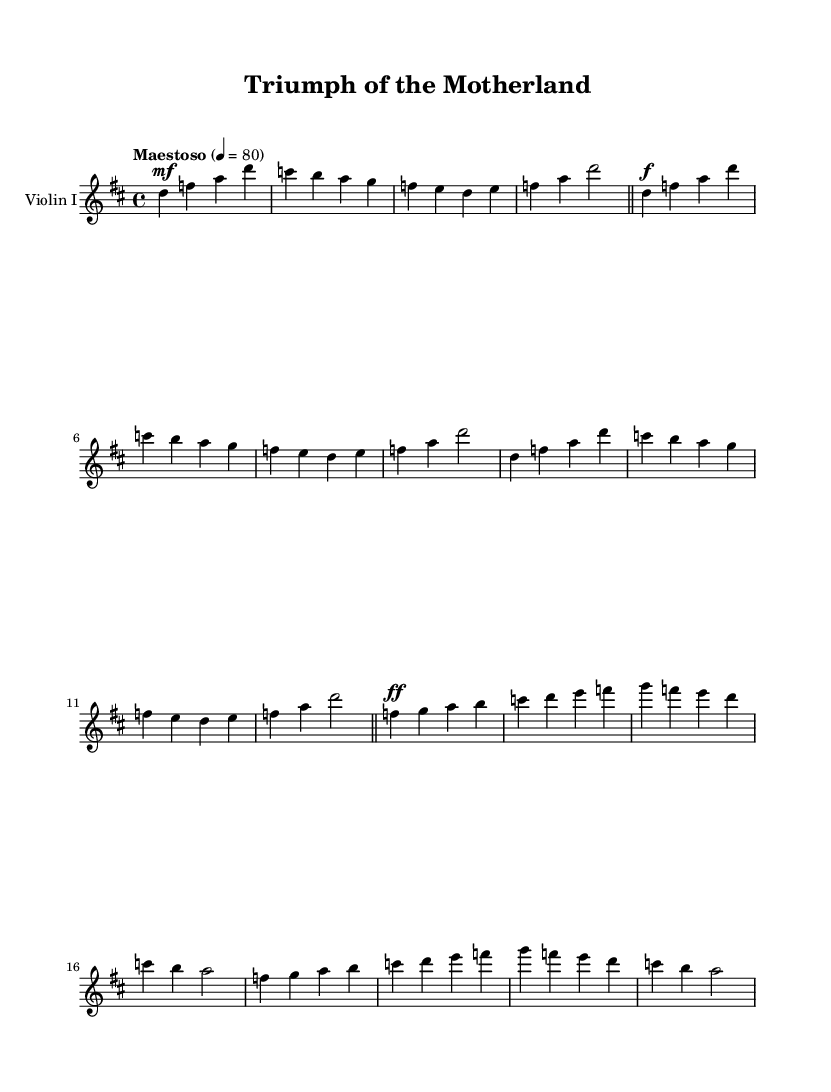What is the key signature of this music? The key signature is indicated at the beginning of the piece. In the music sheet, there are two sharps visible on the staff lines which correspond to F sharp and C sharp, indicating that the piece is in D major.
Answer: D major What is the time signature of this piece? The time signature is displayed at the beginning of the score, showing that it is 4/4 time, which means there are four beats in each measure and the quarter note receives one beat.
Answer: 4/4 What is the indicated tempo marking? The tempo marking is provided at the top of the score, specifying that the piece should be played at a "Maestoso" tempo, which typically indicates a majestic and dignified pace, further quantified as 80 beats per minute.
Answer: Maestoso How many distinct themes are presented in this piece? Upon examining the score, we can see that two different themes are presented: Main Theme A and Main Theme B, each of which has its own unique melodic structure.
Answer: Two What dynamics are indicated for the introduction? The dynamics for the introduction are noted as "mf," which stands for mezzo forte, indicating a moderately loud volume for that section of the music.
Answer: mf Which instrument is specified for this score? The score specifies the instrument at the beginning where it states "Violin I", indicating that this sheet music is meant to be played by the first violin.
Answer: Violin I What is the final measure's note value for the Main Theme B? In the final measure for Main Theme B, the note value is a half note (a dotted half note in this case) which indicates that it should be held for two beats.
Answer: a2 